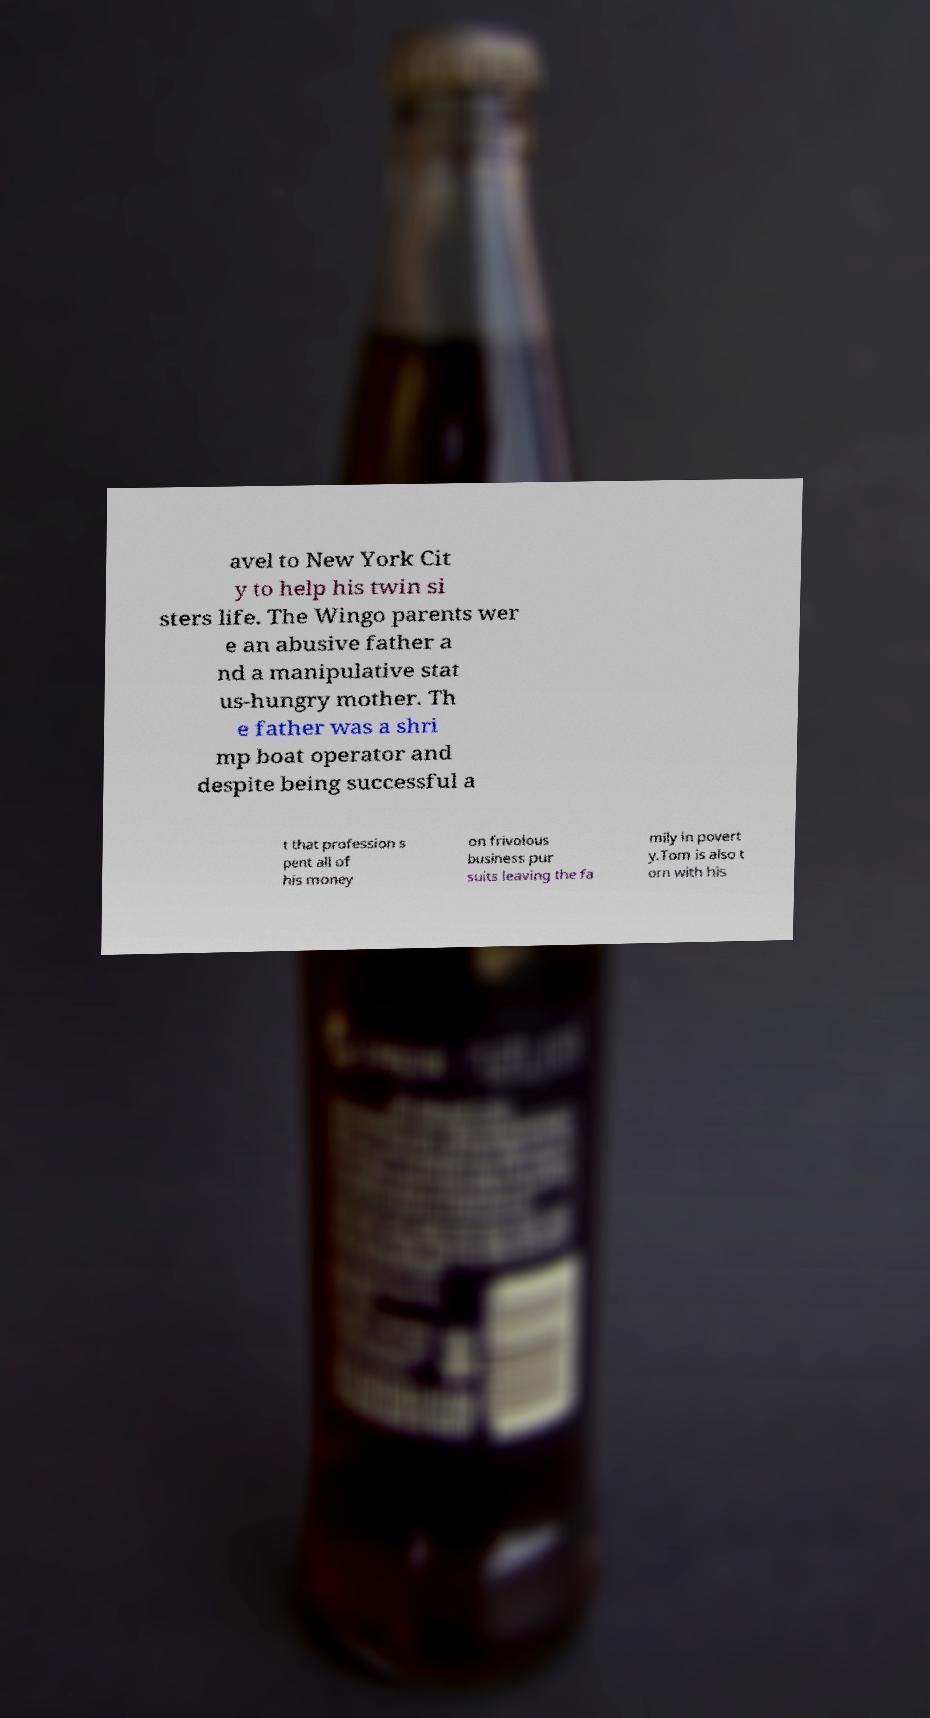Can you accurately transcribe the text from the provided image for me? avel to New York Cit y to help his twin si sters life. The Wingo parents wer e an abusive father a nd a manipulative stat us-hungry mother. Th e father was a shri mp boat operator and despite being successful a t that profession s pent all of his money on frivolous business pur suits leaving the fa mily in povert y.Tom is also t orn with his 